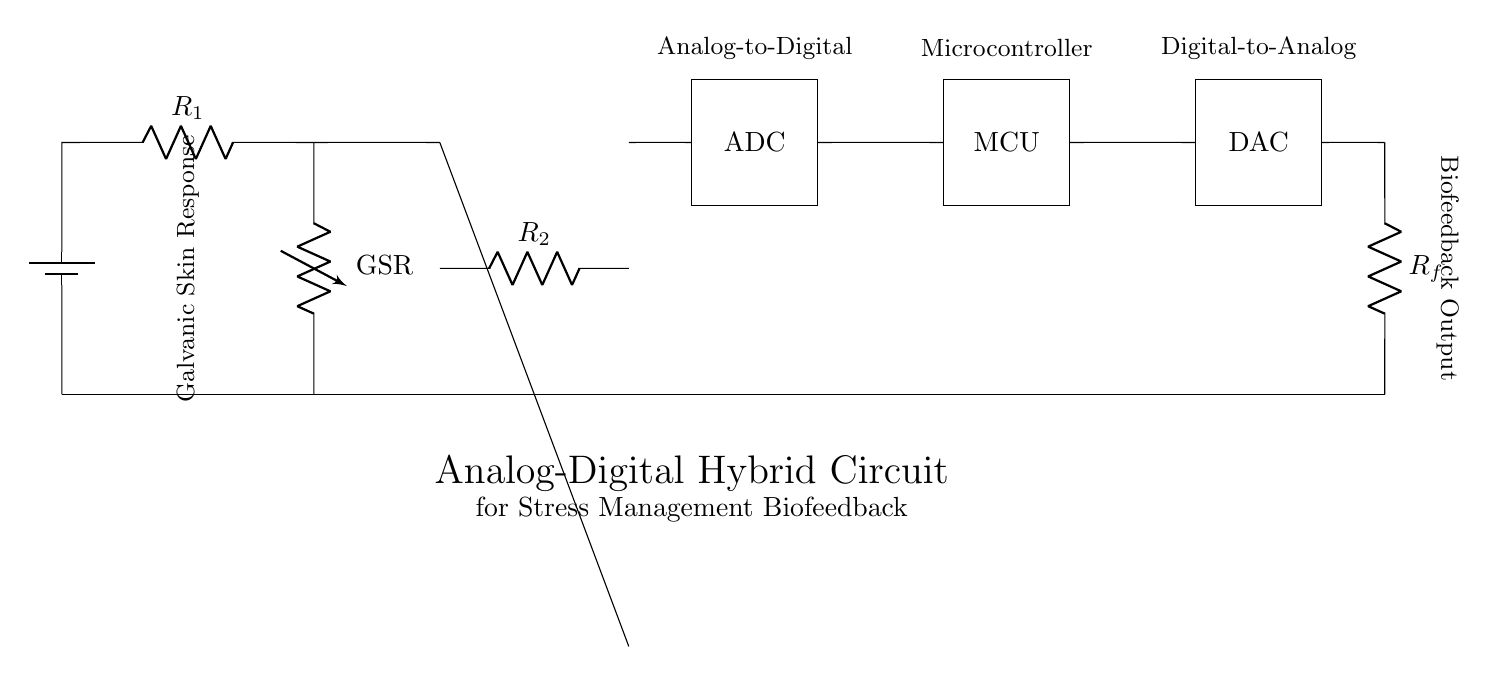What component is used to measure Galvanic Skin Response? The component labeled as "GSR" signifies the Galvanic Skin Response sensor, which measures the electrical conductivity of the skin.
Answer: GSR What is the role of the microcontroller in this circuit? The microcontroller (MCU) receives data from the ADC and processes it to provide feedback to the biofeedback output, managing stress management in real-time.
Answer: Processing What is the purpose of the analog-to-digital converter? The ADC converts the analog signal from the GSR sensor into a digital signal that the microcontroller can interpret for further analysis and response.
Answer: Conversion How many resistors are present in the circuit? Two resistors are indicated: "R1" and "R2" in the analog section, and "Rf" in the feedback loop.
Answer: Three What does the feedback loop connect to in this circuit? The feedback loop connects the output of the DAC back to the input of the GSR sensor, creating a continuous system for real-time feedback.
Answer: GSR What type of circuit does this diagram represent? The diagram represents an analog-digital hybrid circuit, combining both analog components (like the GSR and op-amp) with digital components (like ADC, MCU, and DAC).
Answer: Hybrid 